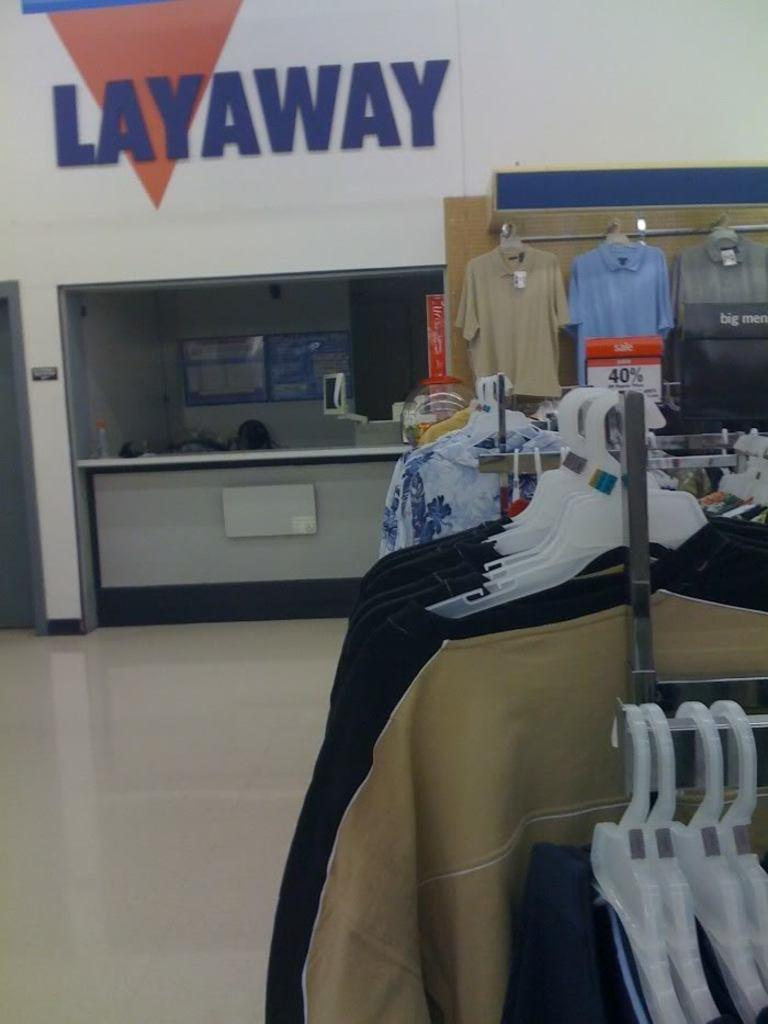What type of establishment is depicted in the image? The image shows an inner view of a store. What items can be seen hanging in the store? There are clothes on hangers in the image. What piece of furniture is present in the store? There is a table in the image. How can customers find out the prices of the items in the store? There is a price display board in the image. What type of news can be heard coming from the clothes in the image? There is no news present in the image, as it features an inner view of a store with clothes on hangers, a table, and a price display board. 